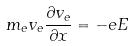<formula> <loc_0><loc_0><loc_500><loc_500>m _ { e } v _ { e } \frac { \partial v _ { e } } { \partial x } = - e E</formula> 